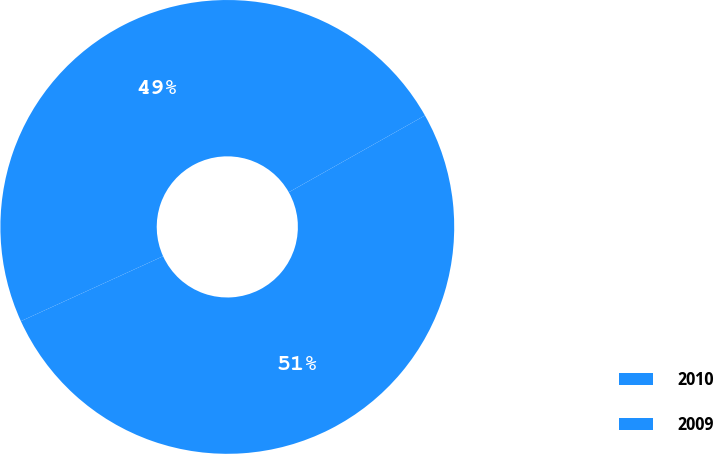Convert chart to OTSL. <chart><loc_0><loc_0><loc_500><loc_500><pie_chart><fcel>2010<fcel>2009<nl><fcel>51.35%<fcel>48.65%<nl></chart> 